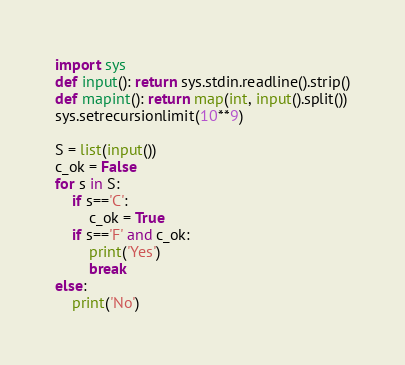Convert code to text. <code><loc_0><loc_0><loc_500><loc_500><_Python_>import sys
def input(): return sys.stdin.readline().strip()
def mapint(): return map(int, input().split())
sys.setrecursionlimit(10**9)

S = list(input())
c_ok = False
for s in S:
    if s=='C':
        c_ok = True
    if s=='F' and c_ok:
        print('Yes')
        break
else:
    print('No')</code> 